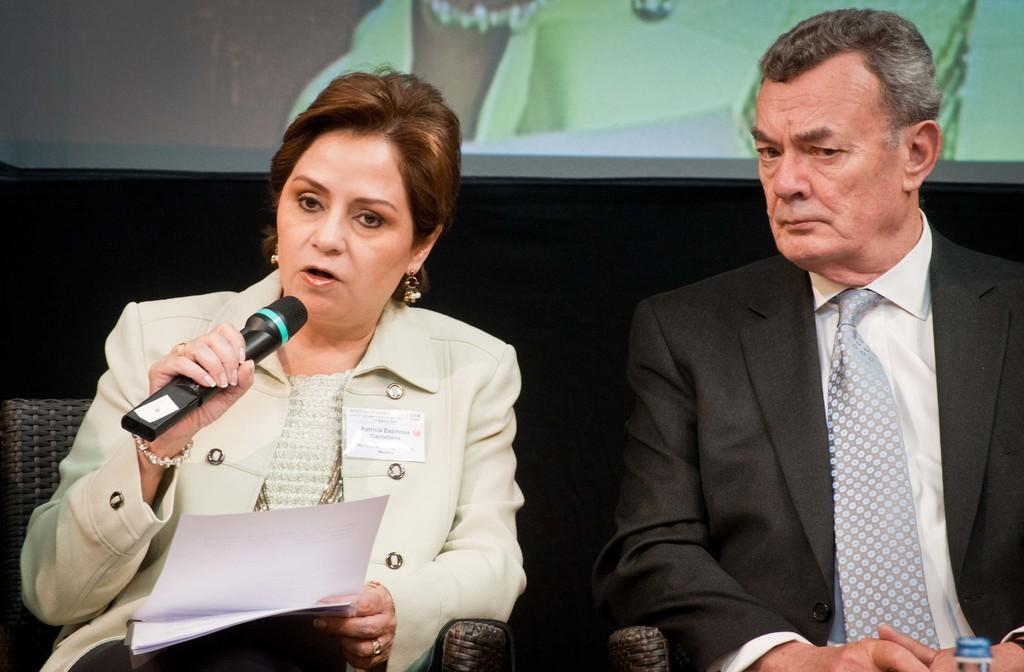How many people are sitting on the couch in the image? There are two persons sitting on the couch in the image. Can you describe the gender of one of the persons? One of the persons is a woman. What is the woman holding in her hands? The woman is holding a paper and a microphone. What can be seen in the background of the image? There is a screen in the background. What type of jam is being prepared on the screen in the image? There is no jam preparation or any reference to jam in the image. 